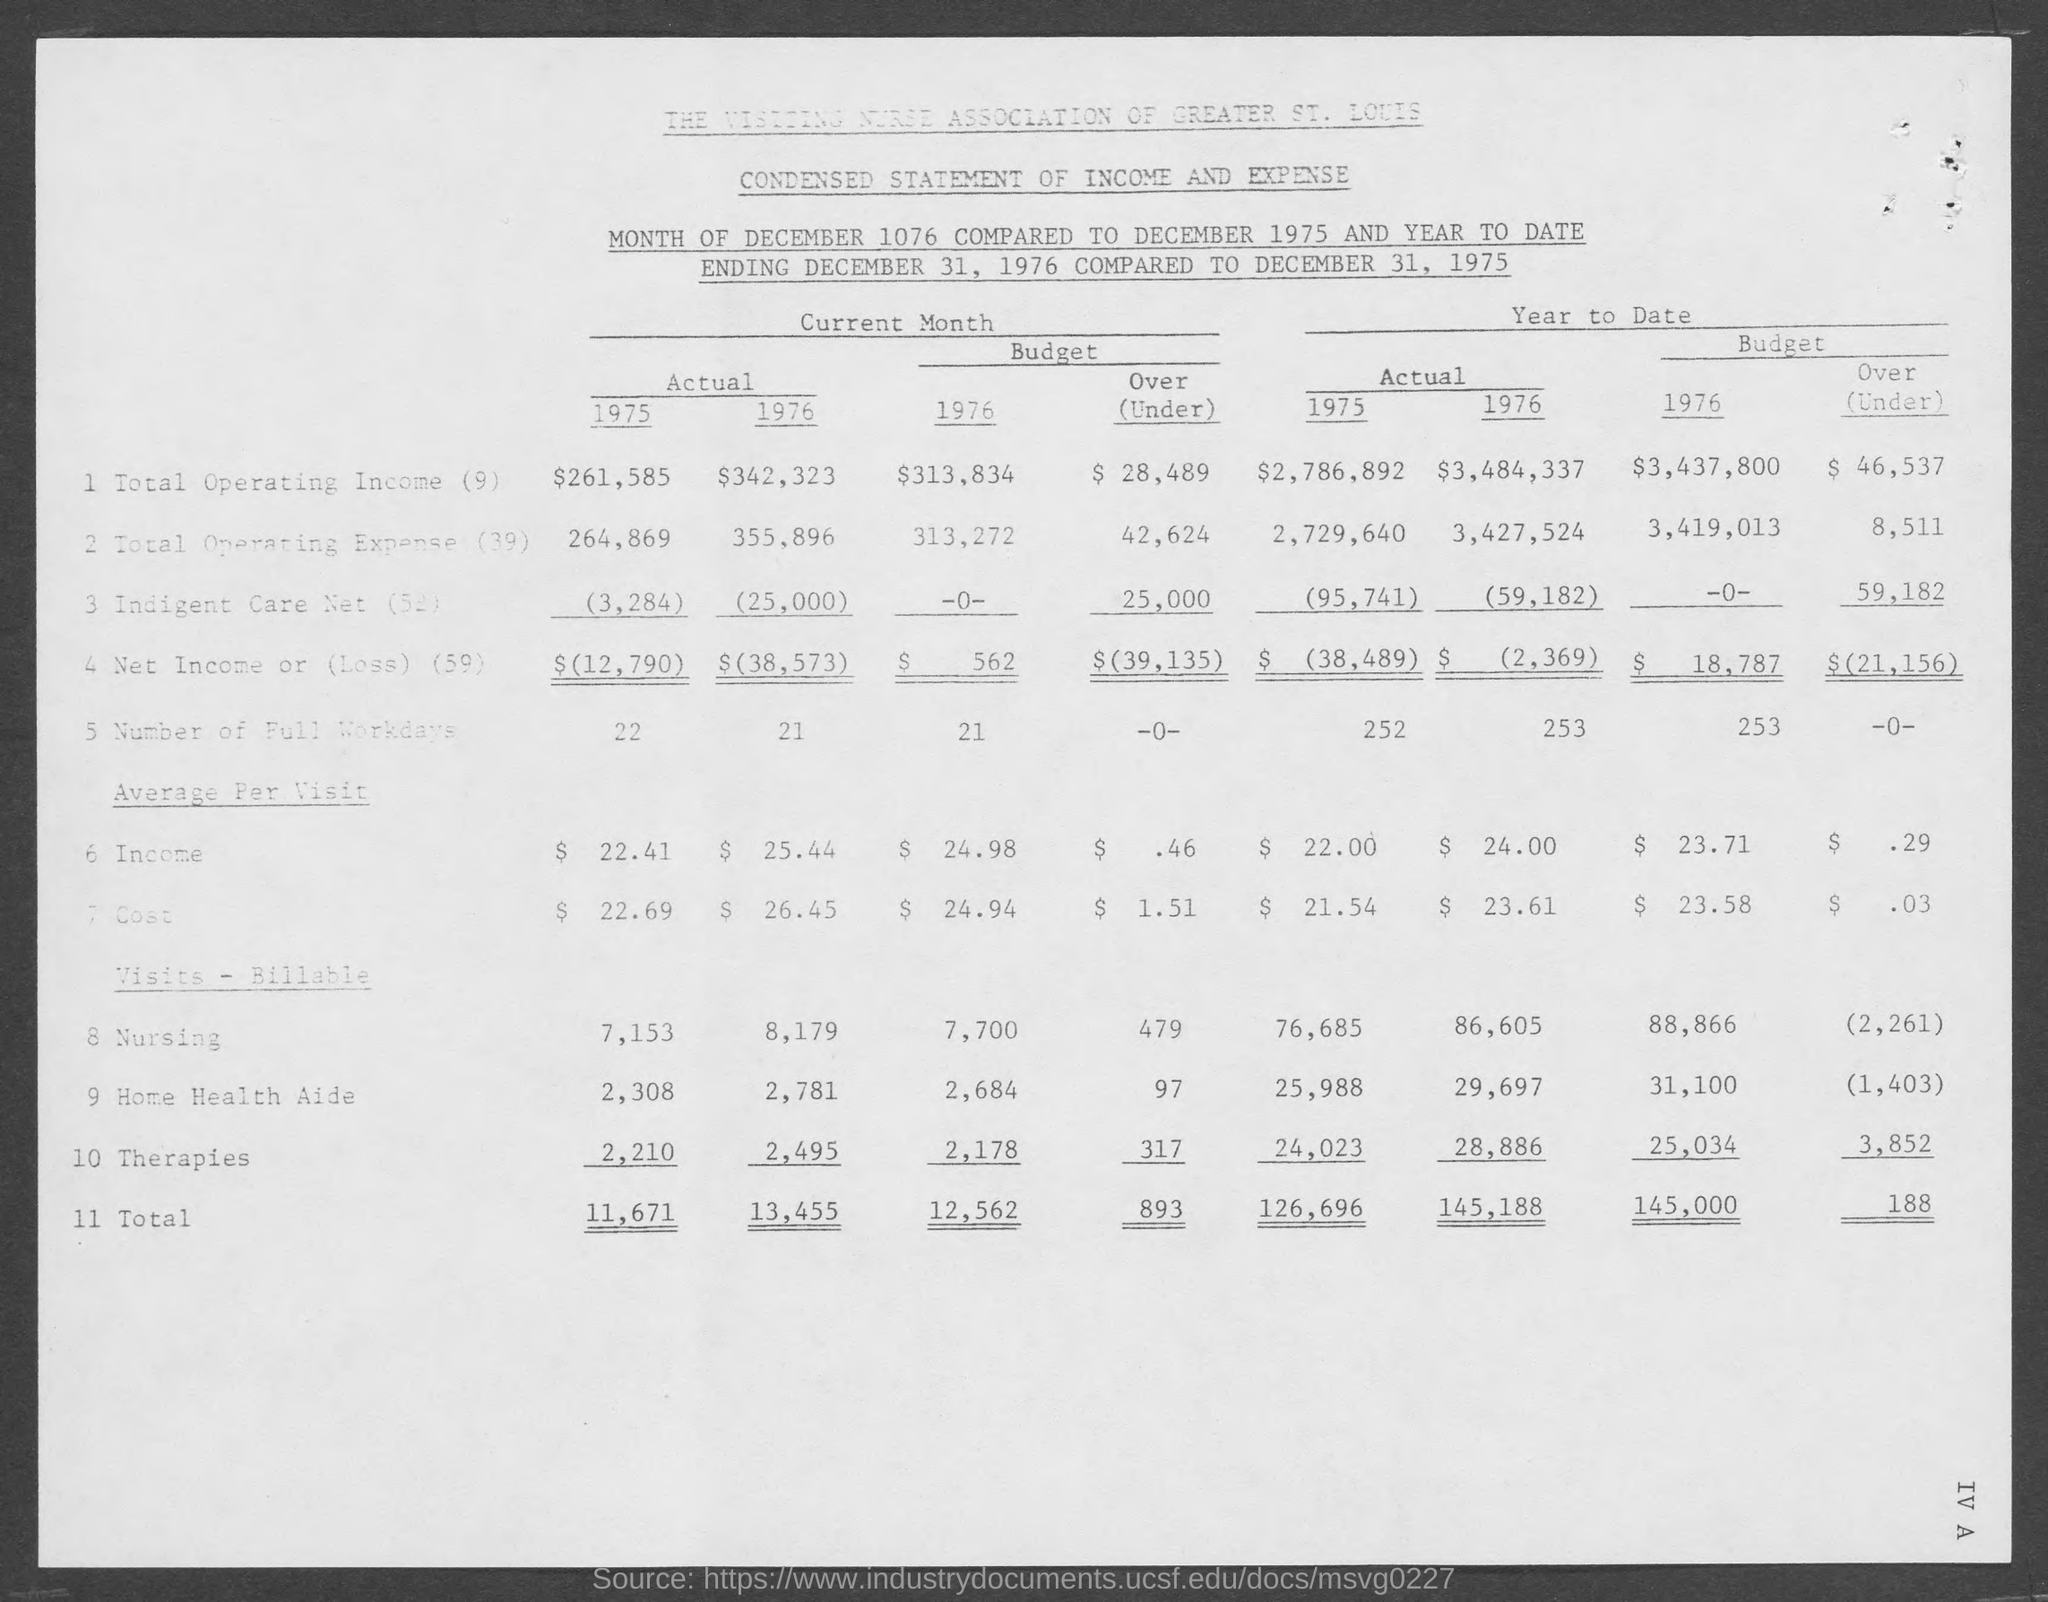Give some essential details in this illustration. The actual total for 1975 is 11,671. The actual average per visit income for 1975 was $22.41. The actual number of full working days in 1975 was 22. The actual total operating income for 1975 was $261,585. 